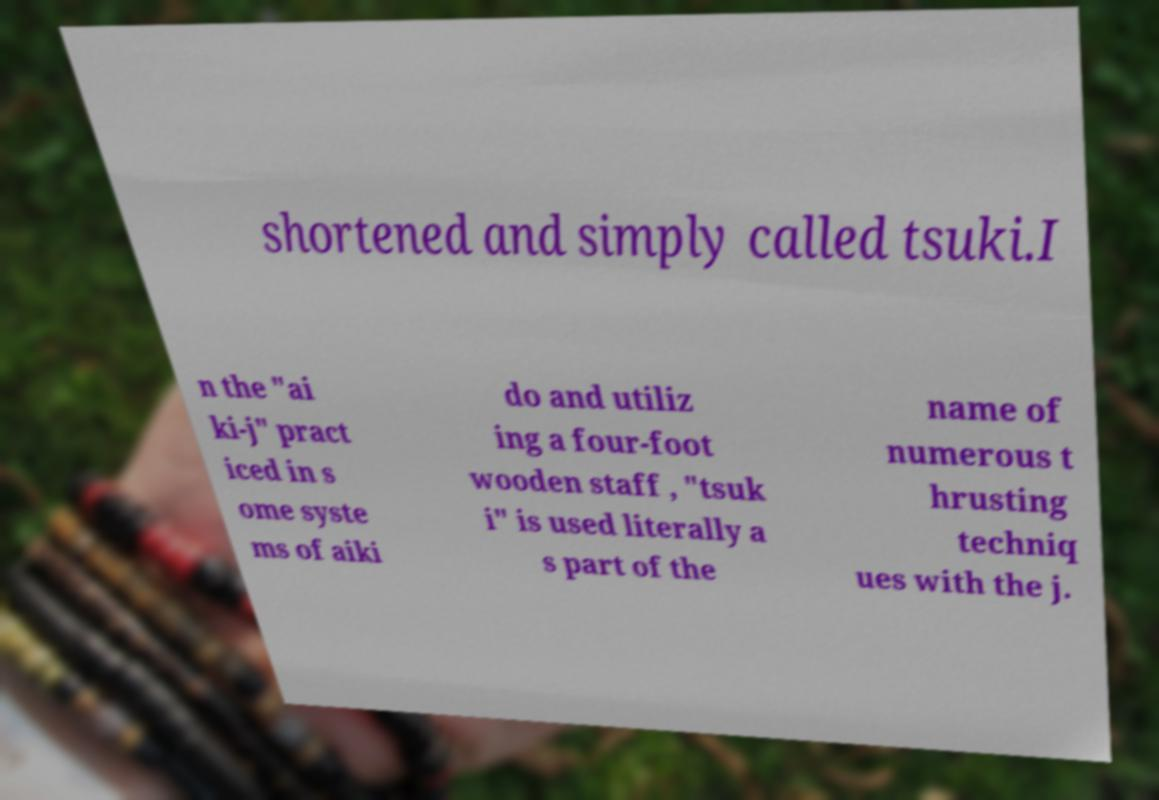What messages or text are displayed in this image? I need them in a readable, typed format. shortened and simply called tsuki.I n the "ai ki-j" pract iced in s ome syste ms of aiki do and utiliz ing a four-foot wooden staff , "tsuk i" is used literally a s part of the name of numerous t hrusting techniq ues with the j. 